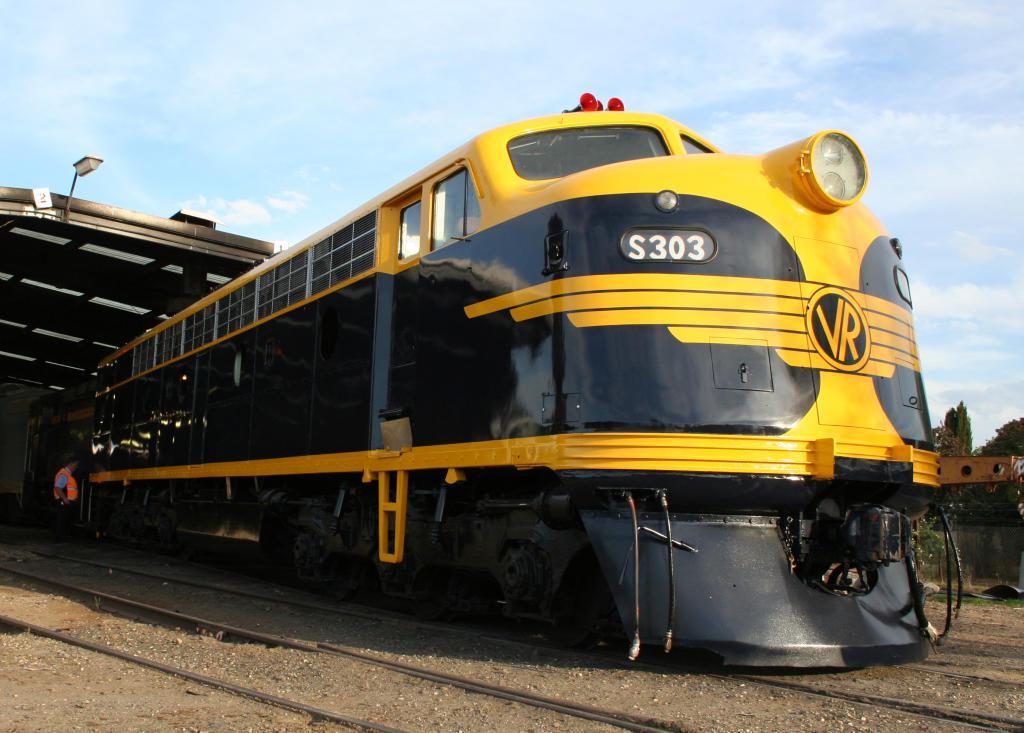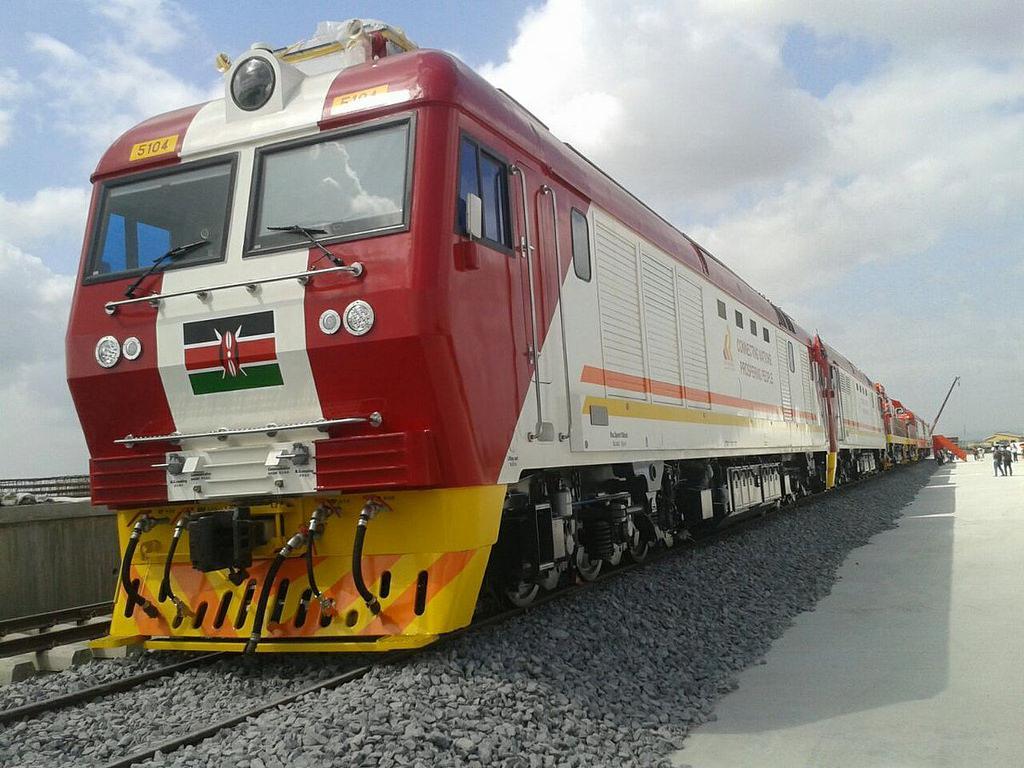The first image is the image on the left, the second image is the image on the right. Considering the images on both sides, is "The train in the right image is facing left." valid? Answer yes or no. Yes. The first image is the image on the left, the second image is the image on the right. Analyze the images presented: Is the assertion "In one image there is a yellow and orange train sitting on rails in the center of the image." valid? Answer yes or no. No. 